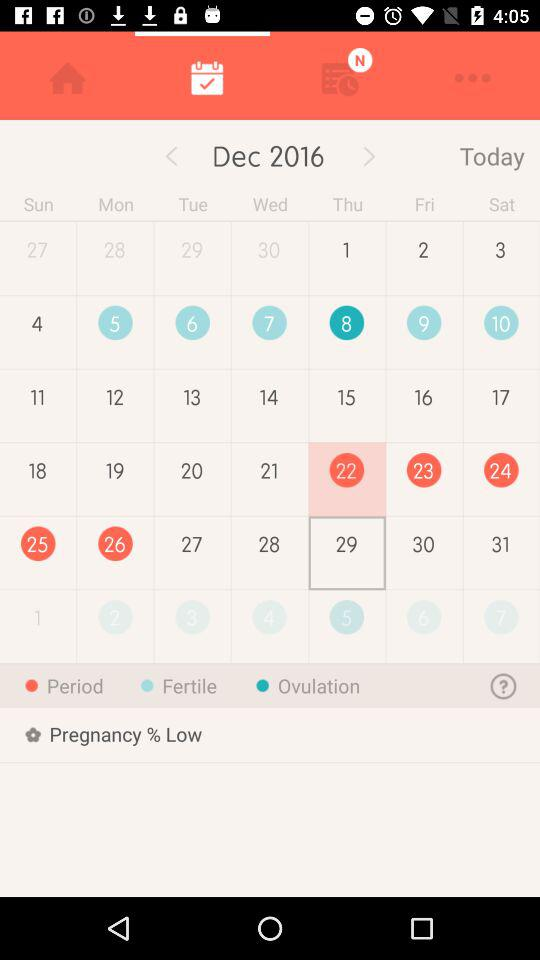What is the "Ovulation" date? The "Ovulation" date is Thursday, December 8, 2016. 